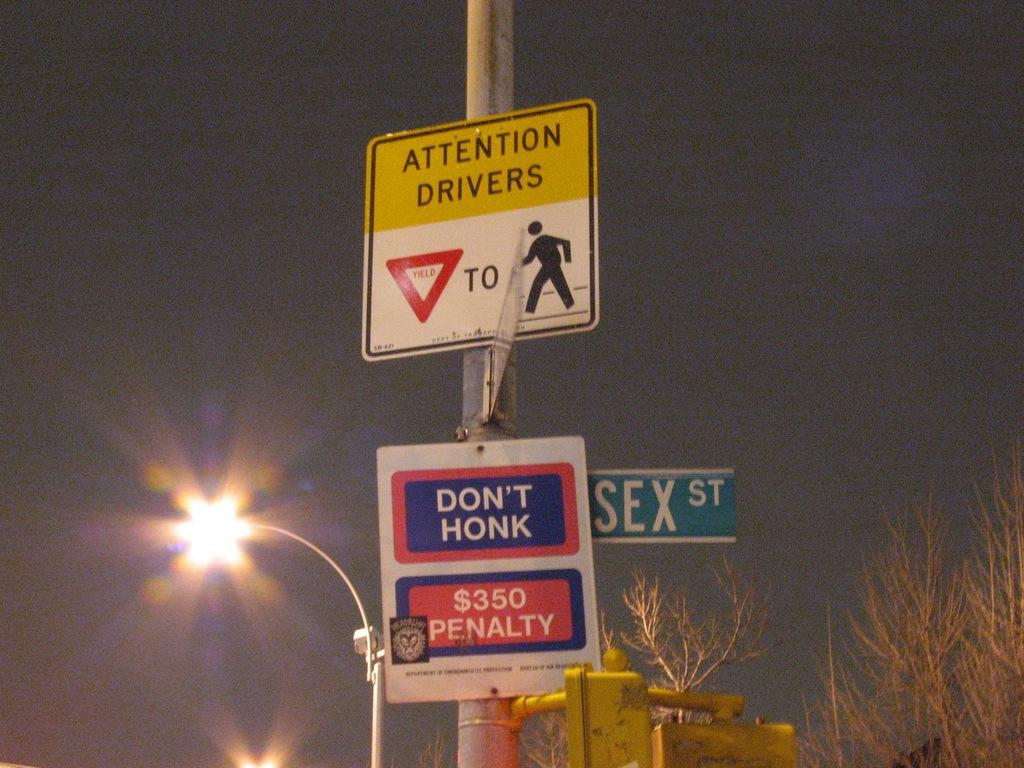<image>
Summarize the visual content of the image. A street lamp glows behind a pole with an attention drivers sign and a no honking sign. 